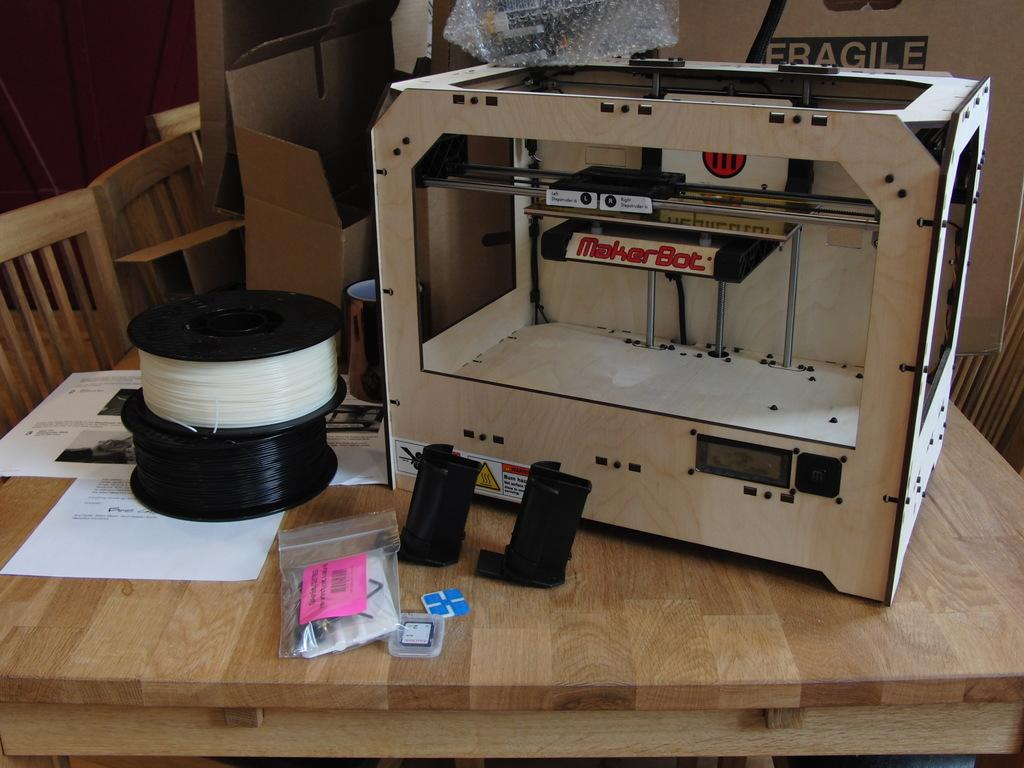What piece of furniture is visible in the image? There is a table present in the image. What device is placed on the table? There is a printer on the table. What else can be seen on the table besides the printer? There are bundles on the table. What type of seating is on the left side of the image? There are chairs on the left side of the image. What object is located at the top of the image? There is a box at the top of the image. What type of cushion is on the table in the image? There is no cushion present on the table in the image. What type of cloth is draped over the printer in the image? There is no cloth draped over the printer in the image. 